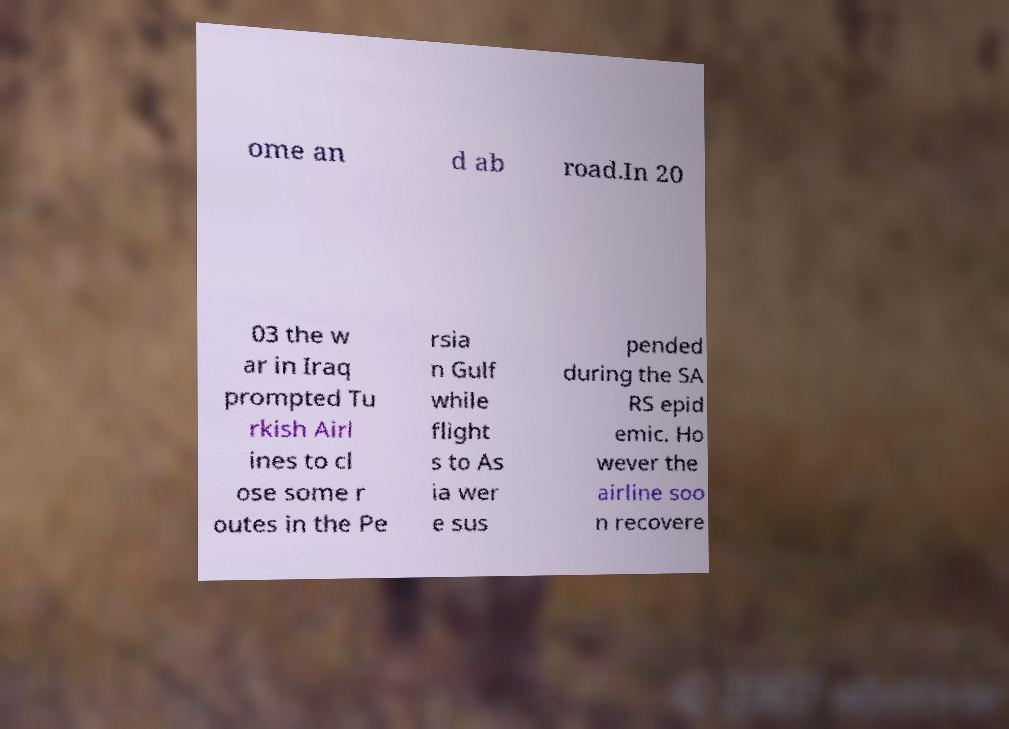I need the written content from this picture converted into text. Can you do that? ome an d ab road.In 20 03 the w ar in Iraq prompted Tu rkish Airl ines to cl ose some r outes in the Pe rsia n Gulf while flight s to As ia wer e sus pended during the SA RS epid emic. Ho wever the airline soo n recovere 